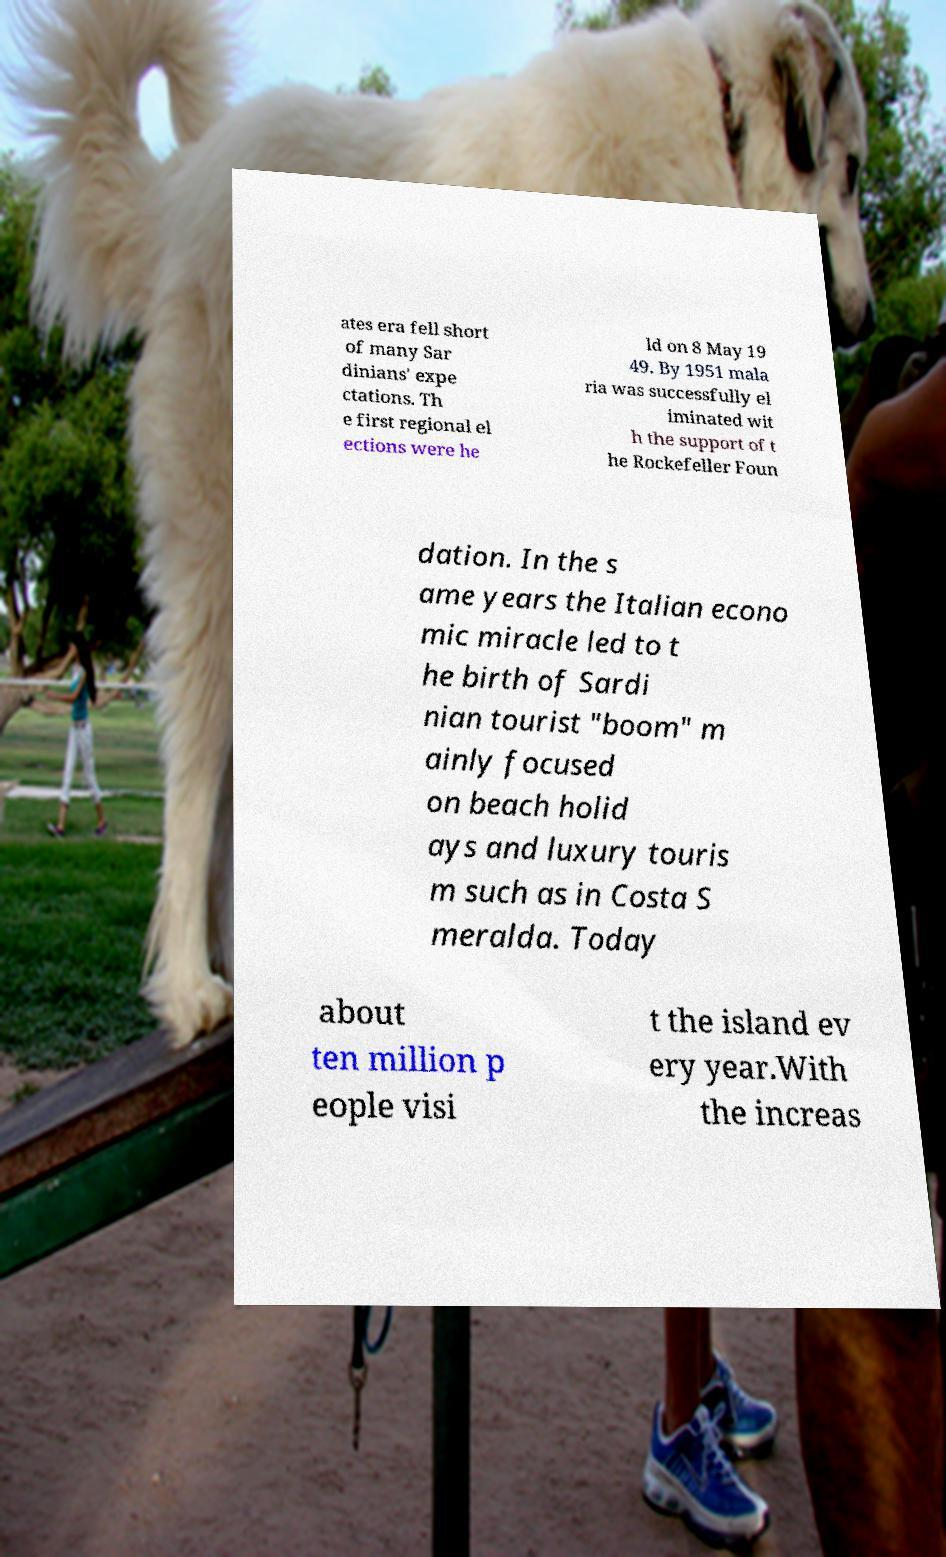Please identify and transcribe the text found in this image. ates era fell short of many Sar dinians' expe ctations. Th e first regional el ections were he ld on 8 May 19 49. By 1951 mala ria was successfully el iminated wit h the support of t he Rockefeller Foun dation. In the s ame years the Italian econo mic miracle led to t he birth of Sardi nian tourist "boom" m ainly focused on beach holid ays and luxury touris m such as in Costa S meralda. Today about ten million p eople visi t the island ev ery year.With the increas 